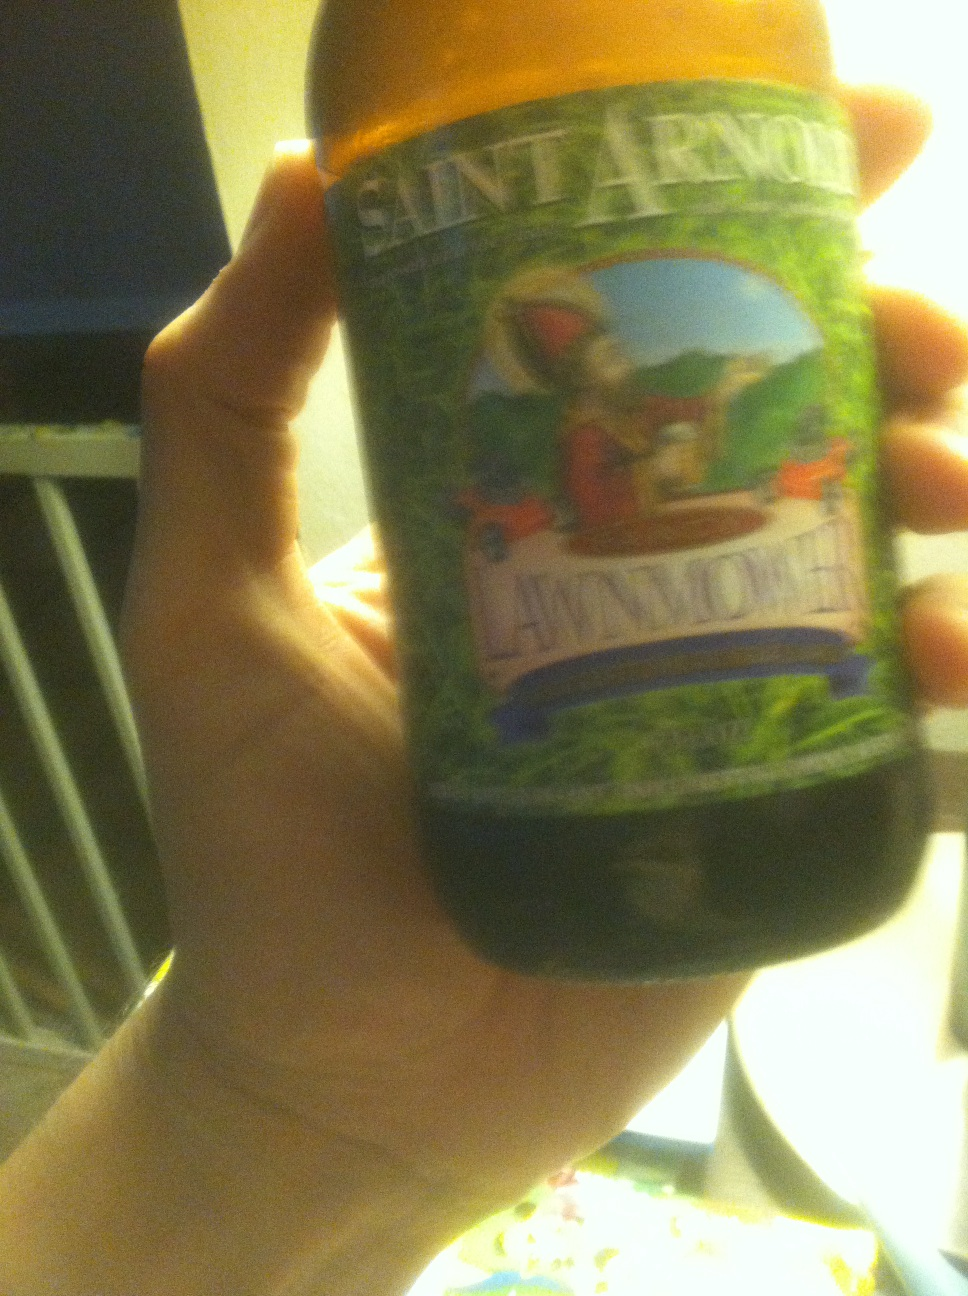Is this type of beer seasonal, or available year-round? Saint Arnold's Lawnmower is available year-round, making it a great choice for both summer and winter months. 